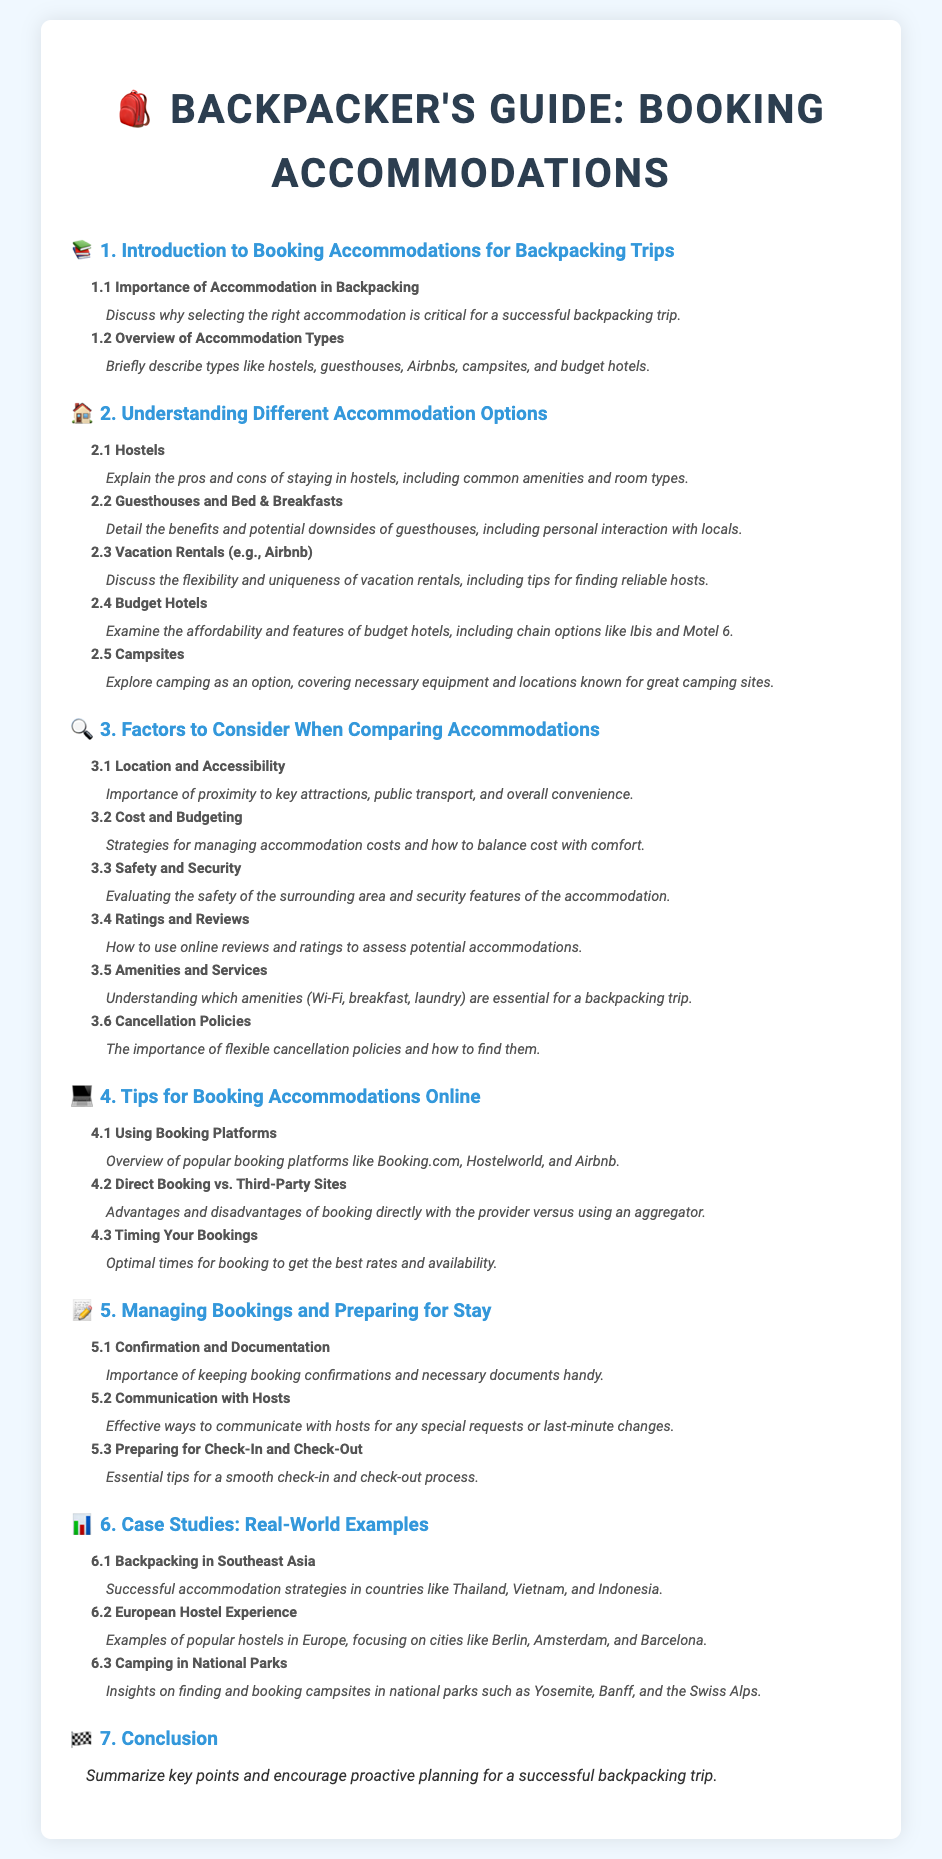What is the title of this document? The title is clearly specified in the document's header.
Answer: Booking Accommodations: Comparing and Selecting the Best Options What section discusses the importance of accommodation? The importance of accommodation is addressed in subsection 1.1.
Answer: 1.1 Importance of Accommodation in Backpacking What are the types of accommodations mentioned? The document lists various accommodation types in section 1.2.
Answer: hostels, guesthouses, Airbnbs, campsites, budget hotels What is discussed in subsection 3.2? Subsection 3.2 focuses on financial aspects of accommodations.
Answer: Cost and Budgeting How many subsections are under section 3? The number of subsections represents specific factors related to accommodations.
Answer: 6 What does subsection 4.1 cover? Subsection 4.1 provides an overview of booking platforms.
Answer: Using Booking Platforms Which factors are considered in section 3? Section 3 includes several specific factors when comparing accommodations.
Answer: Location and Accessibility, Cost and Budgeting, Safety and Security, Ratings and Reviews, Amenities and Services, Cancellation Policies What is the focus of section 6.2? Section 6.2 highlights a particular accommodation experience in a specific region.
Answer: European Hostel Experience What is the last section of the document? The final section provides concluding insights based on the document's content.
Answer: Conclusion 